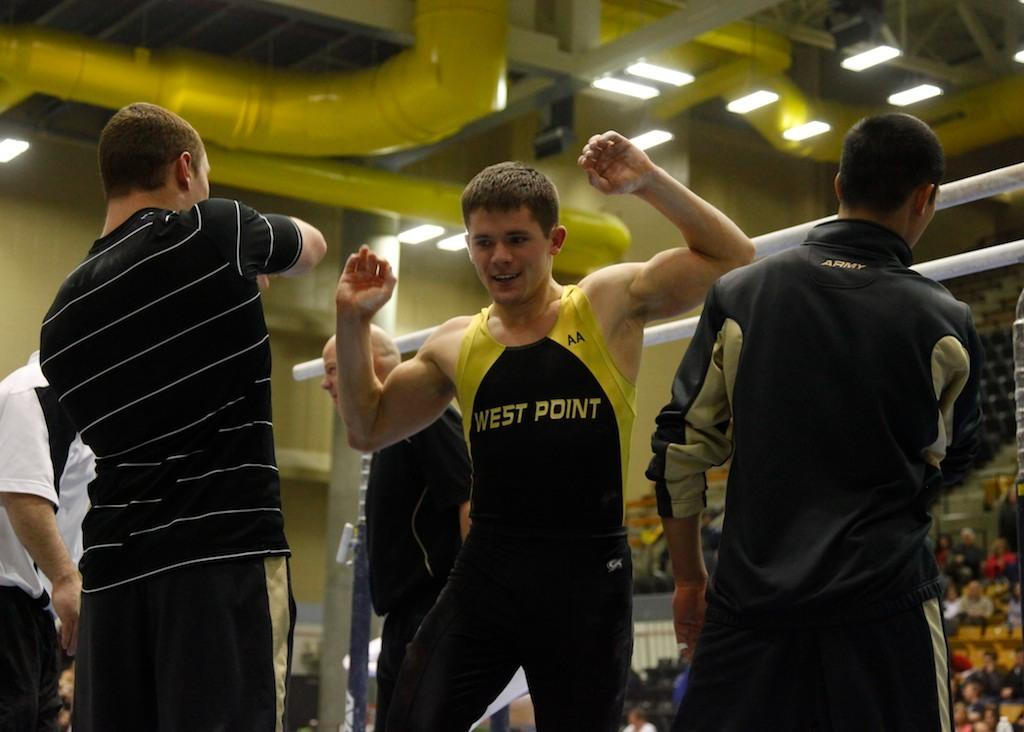<image>
Offer a succinct explanation of the picture presented. Men working out and exercising, while one man is wearing a west point workout shirt. 